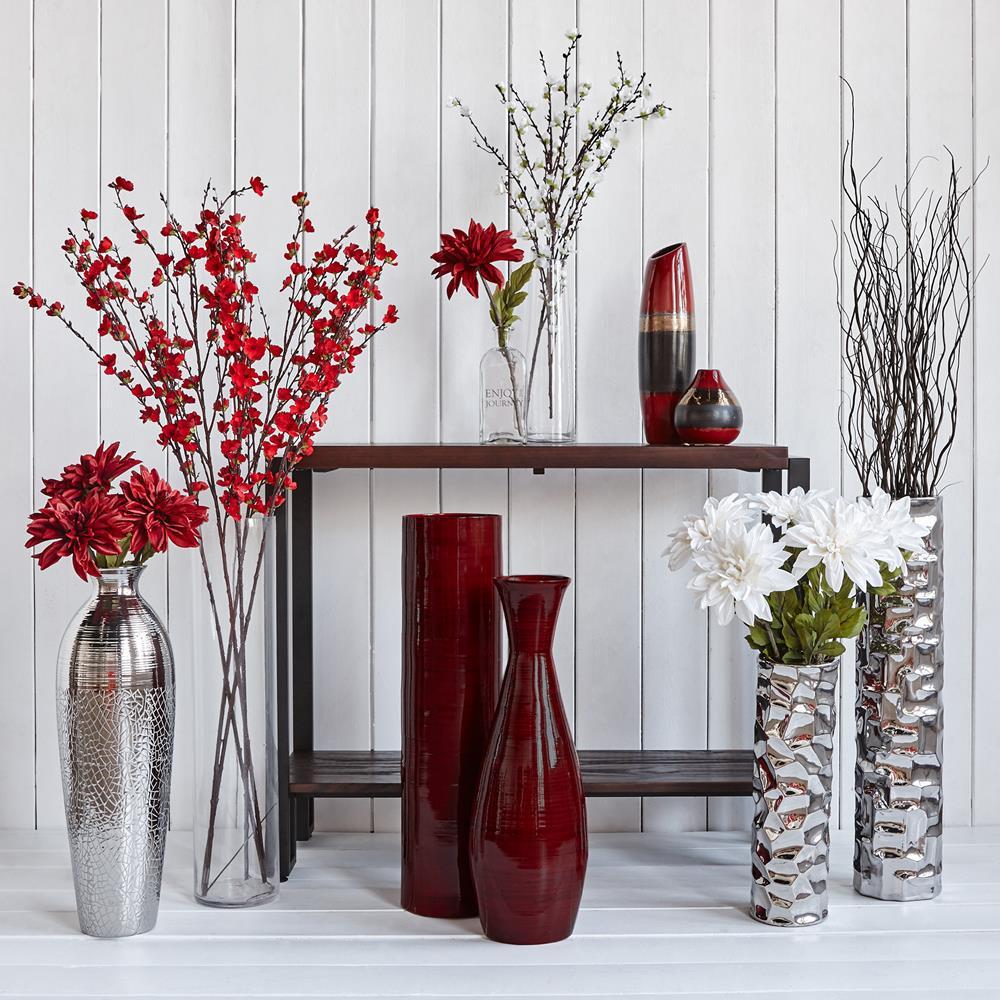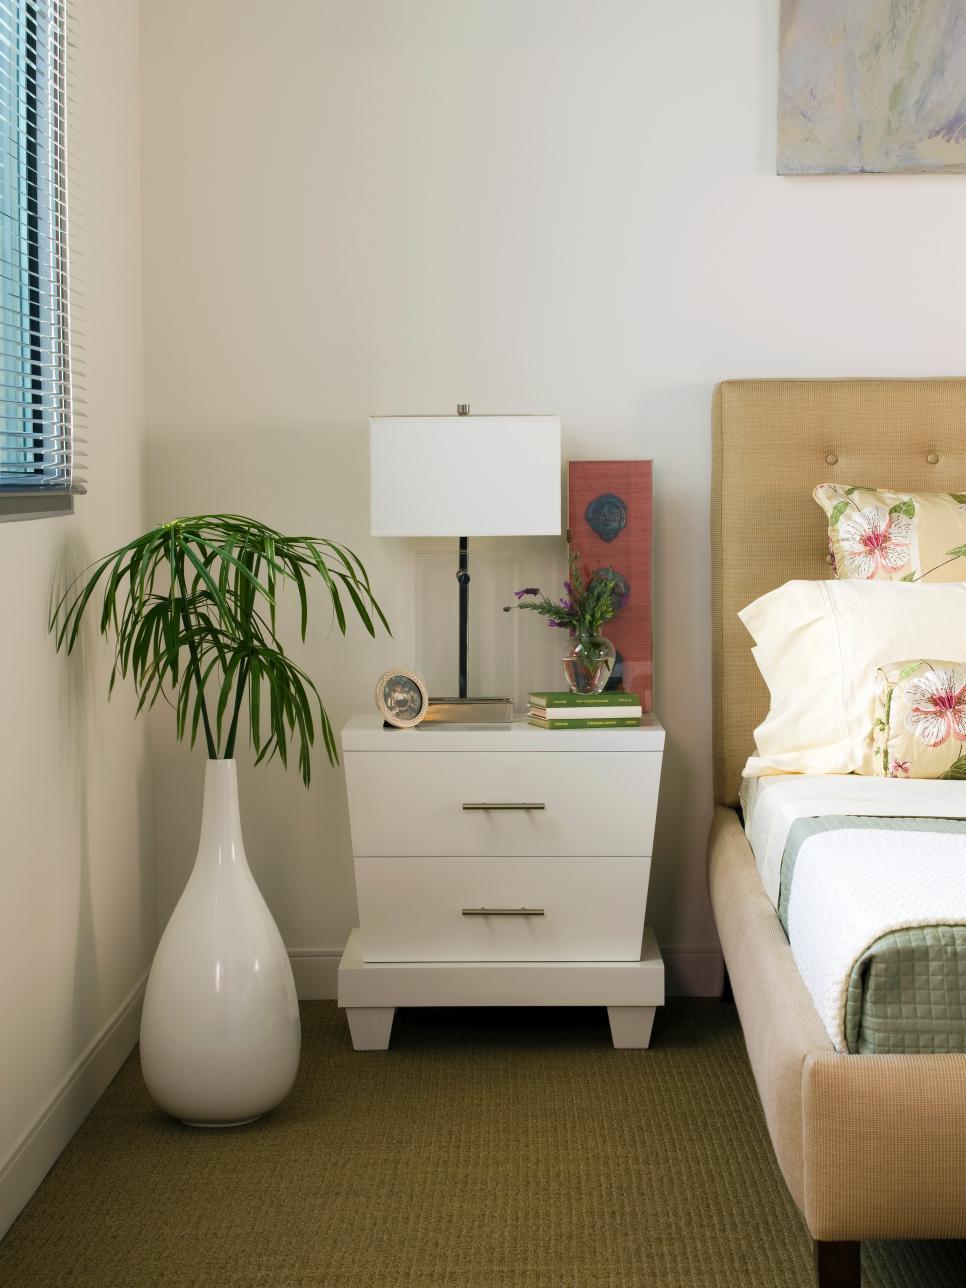The first image is the image on the left, the second image is the image on the right. Analyze the images presented: Is the assertion "Each image includes at least one vase that holds branches that extend upward instead of drooping leaves and includes at least one vase that sits on the floor." valid? Answer yes or no. No. 